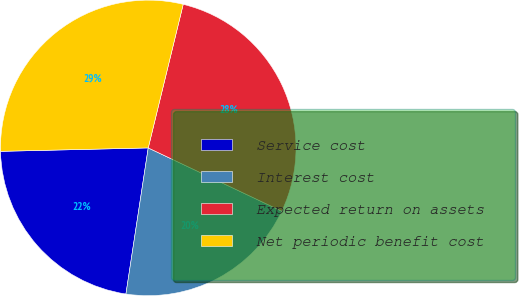Convert chart. <chart><loc_0><loc_0><loc_500><loc_500><pie_chart><fcel>Service cost<fcel>Interest cost<fcel>Expected return on assets<fcel>Net periodic benefit cost<nl><fcel>22.22%<fcel>20.37%<fcel>28.24%<fcel>29.17%<nl></chart> 